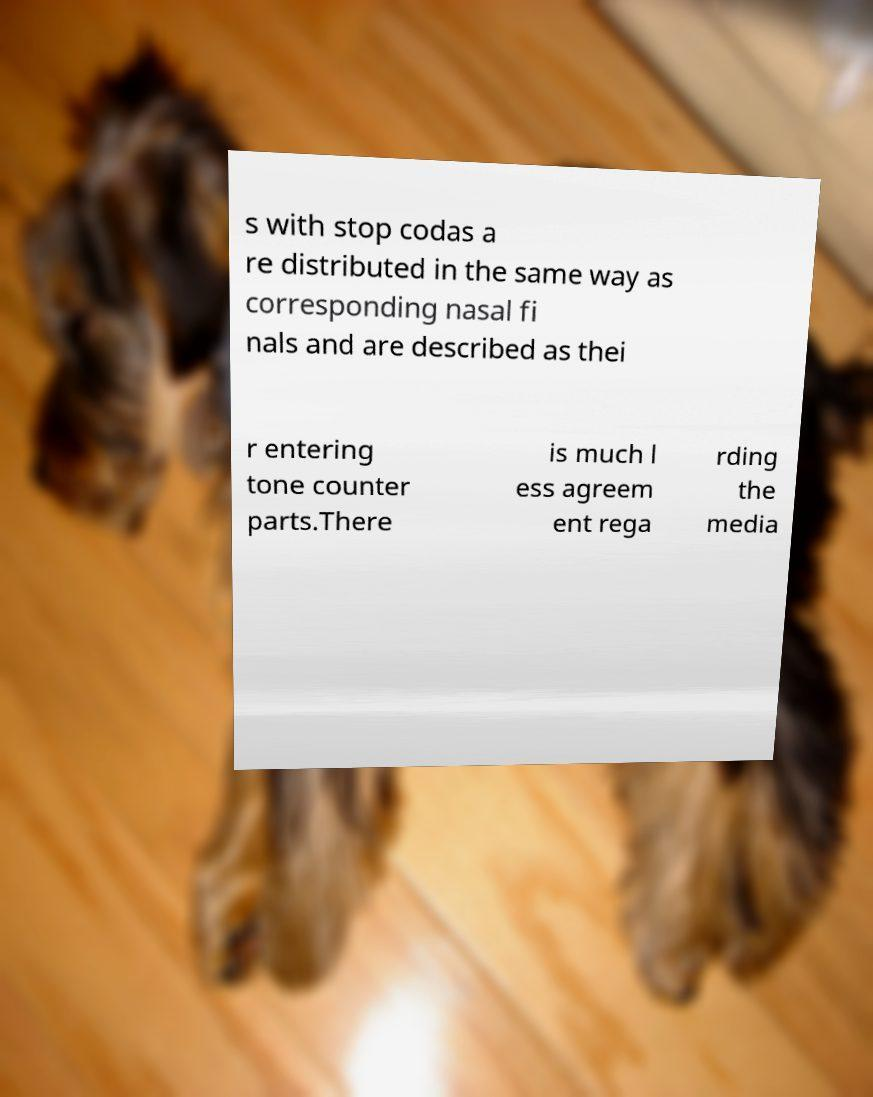Could you assist in decoding the text presented in this image and type it out clearly? s with stop codas a re distributed in the same way as corresponding nasal fi nals and are described as thei r entering tone counter parts.There is much l ess agreem ent rega rding the media 